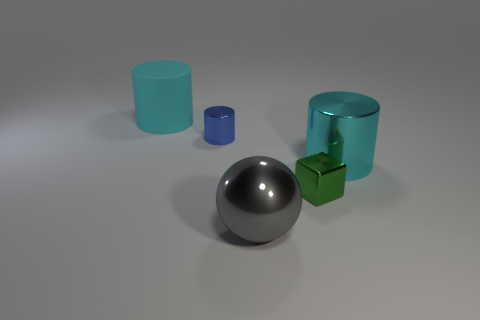What is the material of the green object that is left of the large cyan cylinder that is in front of the big cylinder that is behind the cyan metal thing?
Give a very brief answer. Metal. Are there fewer tiny red objects than tiny blue metallic cylinders?
Give a very brief answer. Yes. Is the small blue thing made of the same material as the green thing?
Offer a terse response. Yes. There is a object that is right of the green metallic object; does it have the same color as the big rubber object?
Make the answer very short. Yes. What number of big cyan metallic things are to the right of the cyan thing that is in front of the cyan rubber cylinder?
Your response must be concise. 0. There is a object that is the same size as the green shiny block; what is its color?
Your answer should be compact. Blue. There is a cyan thing to the left of the big cyan metallic object; what material is it?
Your answer should be very brief. Rubber. There is a object that is both to the right of the tiny blue metallic object and behind the green block; what material is it?
Ensure brevity in your answer.  Metal. Is the size of the metallic cylinder that is right of the block the same as the small blue metallic thing?
Ensure brevity in your answer.  No. What is the shape of the gray shiny object?
Your answer should be compact. Sphere. 